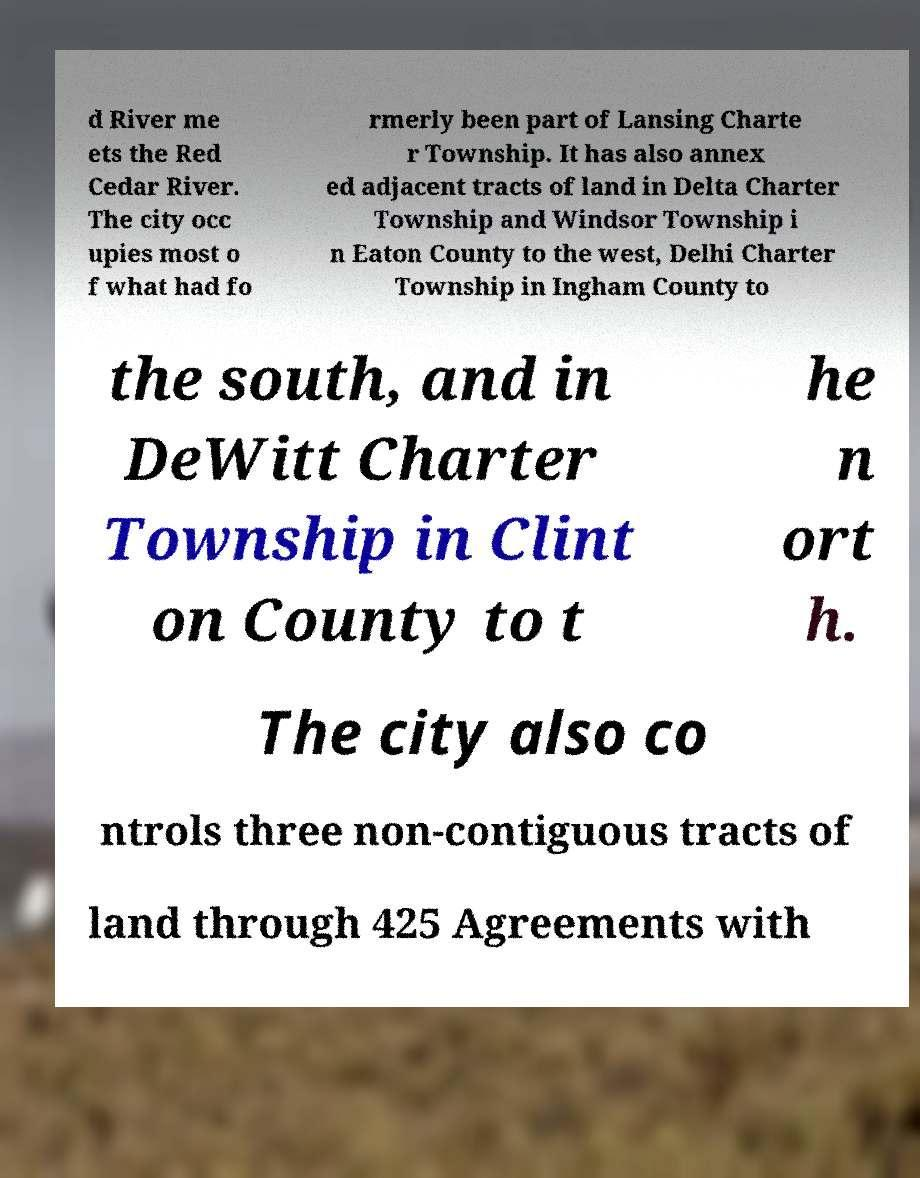I need the written content from this picture converted into text. Can you do that? d River me ets the Red Cedar River. The city occ upies most o f what had fo rmerly been part of Lansing Charte r Township. It has also annex ed adjacent tracts of land in Delta Charter Township and Windsor Township i n Eaton County to the west, Delhi Charter Township in Ingham County to the south, and in DeWitt Charter Township in Clint on County to t he n ort h. The city also co ntrols three non-contiguous tracts of land through 425 Agreements with 